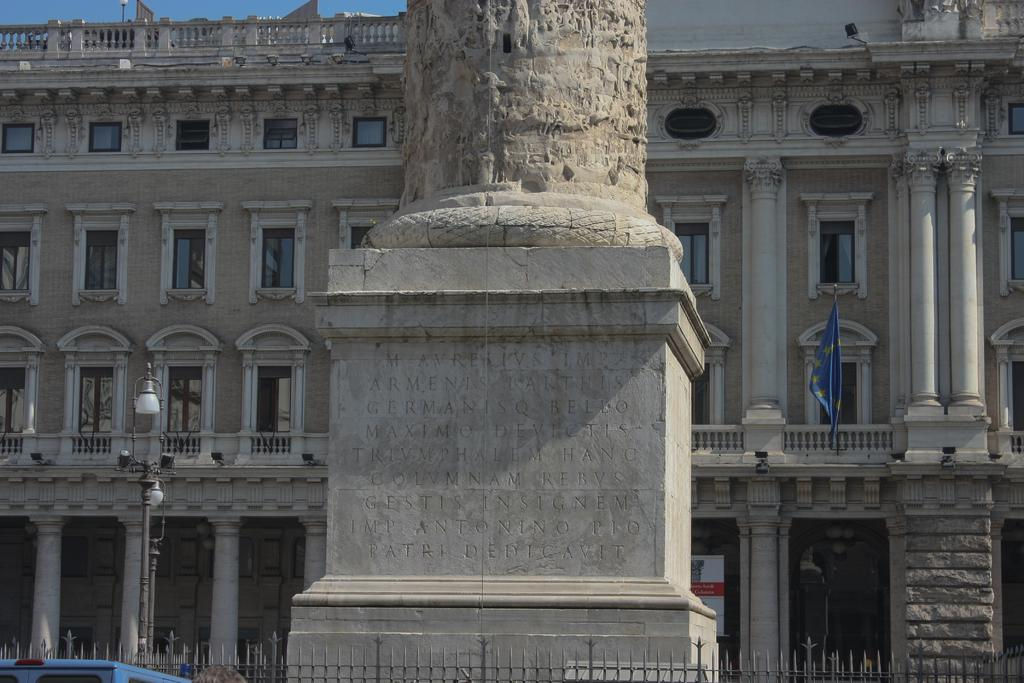What type of structure can be seen in the image? There is a building in the image. What is located near the building? There is a rail in the image. What can be seen flying near the building? There is a flag in the image. What type of maid is present in the image? There is no maid present in the image. What emotion can be seen on the faces of the people in the image? There are no people present in the image, so it is not possible to determine their emotions. 